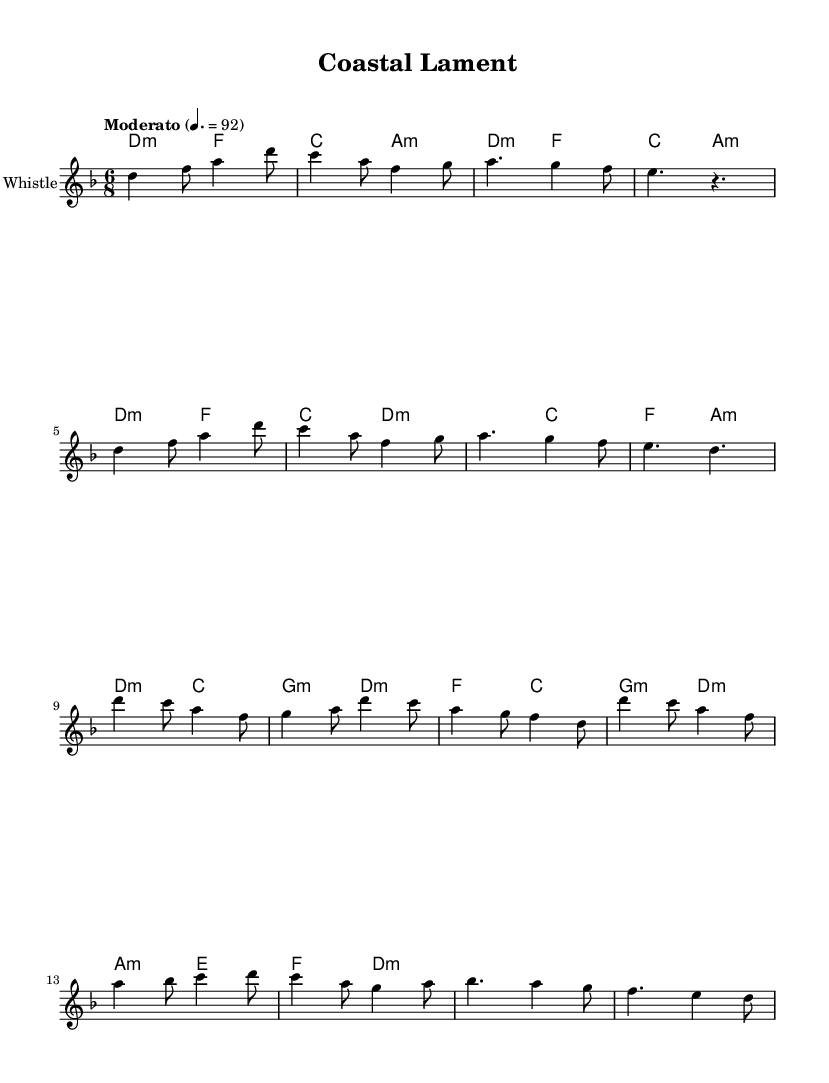What is the key signature of this music? The key signature is indicated at the beginning of the piece, and in this score, there is one flat, which corresponds to the key of D minor.
Answer: D minor What is the time signature of the piece? The time signature appears right after the key signature and is noted as 6/8 in the score, which means there are six eighth notes per measure.
Answer: 6/8 What is the tempo marking for this piece? The tempo marking is indicated in the score as "Moderato" with a metronome marking of 4. = 92, describing a moderate pace.
Answer: Moderato What is the main theme of the lyrics? The lyrics express concern for coastal habitats and emphasize the importance of protection and preservation for wildlife, specifically highlighted through the phrase “protect our coastal home.”
Answer: Protect coastal habitats How many sections are included in the provided music? The music includes four distinct sections: Intro, Verse, Chorus, and Bridge, each contributing to the overall structure of the piece.
Answer: Four What is the dynamics used in the chorus section? The score does not explicitly indicate dynamics, but in Celtic-influenced songs like this, the chorus is typically more expressive; based on the context, we can infer a stronger delivery.
Answer: Stronger What instruments are used in this composition? The title indicates the instrument used for this score is the Tin Whistle, which is also confirmed within the staff notation.
Answer: Tin Whistle 